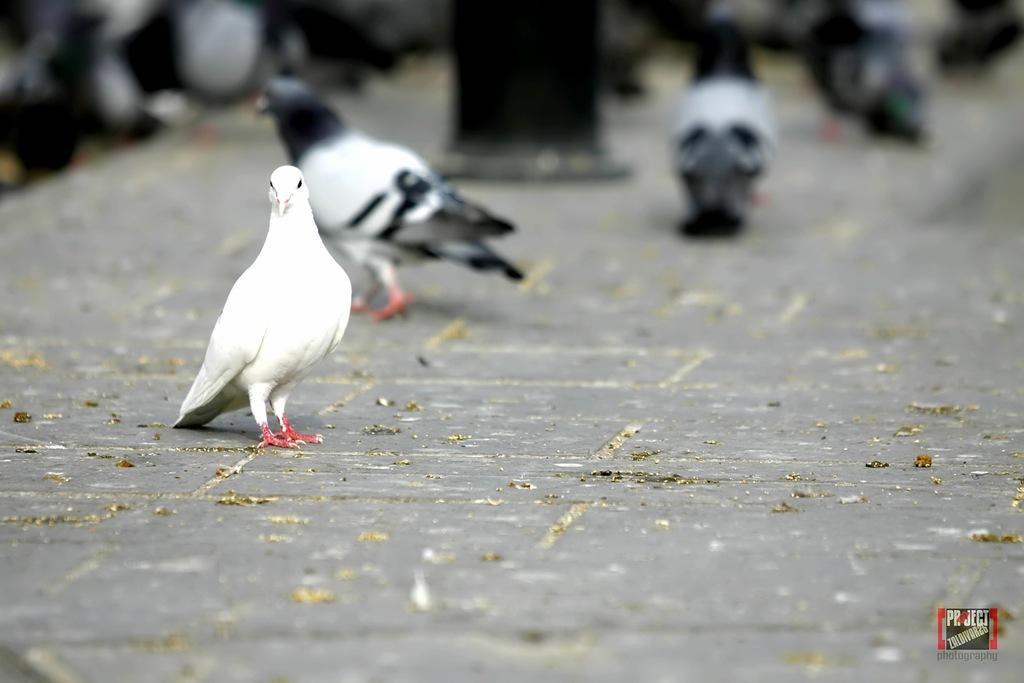How would you summarize this image in a sentence or two? In this picture there is a white color bird on the street. Here we can see many birds standing near to the black pole. On the bottom right corner there is a watermark. 